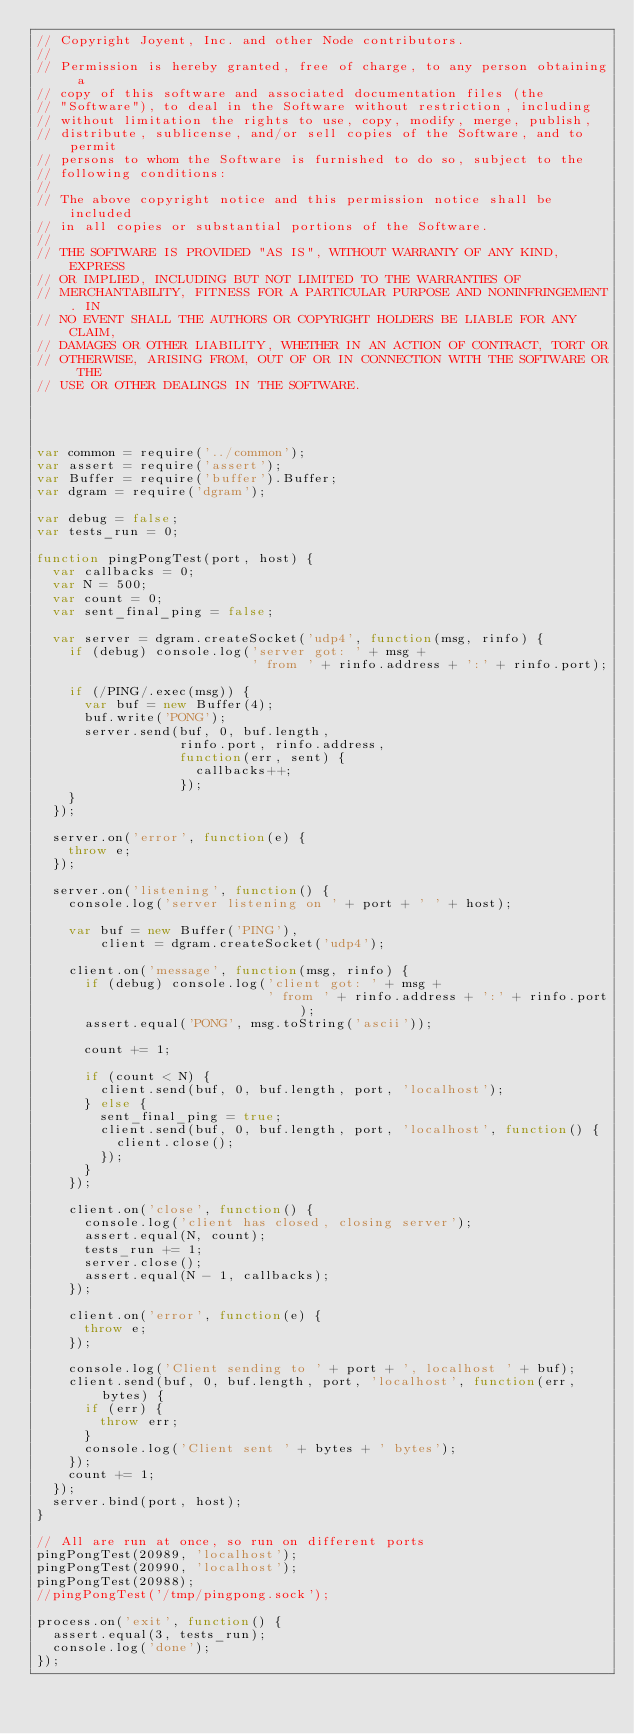<code> <loc_0><loc_0><loc_500><loc_500><_JavaScript_>// Copyright Joyent, Inc. and other Node contributors.
//
// Permission is hereby granted, free of charge, to any person obtaining a
// copy of this software and associated documentation files (the
// "Software"), to deal in the Software without restriction, including
// without limitation the rights to use, copy, modify, merge, publish,
// distribute, sublicense, and/or sell copies of the Software, and to permit
// persons to whom the Software is furnished to do so, subject to the
// following conditions:
//
// The above copyright notice and this permission notice shall be included
// in all copies or substantial portions of the Software.
//
// THE SOFTWARE IS PROVIDED "AS IS", WITHOUT WARRANTY OF ANY KIND, EXPRESS
// OR IMPLIED, INCLUDING BUT NOT LIMITED TO THE WARRANTIES OF
// MERCHANTABILITY, FITNESS FOR A PARTICULAR PURPOSE AND NONINFRINGEMENT. IN
// NO EVENT SHALL THE AUTHORS OR COPYRIGHT HOLDERS BE LIABLE FOR ANY CLAIM,
// DAMAGES OR OTHER LIABILITY, WHETHER IN AN ACTION OF CONTRACT, TORT OR
// OTHERWISE, ARISING FROM, OUT OF OR IN CONNECTION WITH THE SOFTWARE OR THE
// USE OR OTHER DEALINGS IN THE SOFTWARE.




var common = require('../common');
var assert = require('assert');
var Buffer = require('buffer').Buffer;
var dgram = require('dgram');

var debug = false;
var tests_run = 0;

function pingPongTest(port, host) {
  var callbacks = 0;
  var N = 500;
  var count = 0;
  var sent_final_ping = false;

  var server = dgram.createSocket('udp4', function(msg, rinfo) {
    if (debug) console.log('server got: ' + msg +
                           ' from ' + rinfo.address + ':' + rinfo.port);

    if (/PING/.exec(msg)) {
      var buf = new Buffer(4);
      buf.write('PONG');
      server.send(buf, 0, buf.length,
                  rinfo.port, rinfo.address,
                  function(err, sent) {
                    callbacks++;
                  });
    }
  });

  server.on('error', function(e) {
    throw e;
  });

  server.on('listening', function() {
    console.log('server listening on ' + port + ' ' + host);

    var buf = new Buffer('PING'),
        client = dgram.createSocket('udp4');

    client.on('message', function(msg, rinfo) {
      if (debug) console.log('client got: ' + msg +
                             ' from ' + rinfo.address + ':' + rinfo.port);
      assert.equal('PONG', msg.toString('ascii'));

      count += 1;

      if (count < N) {
        client.send(buf, 0, buf.length, port, 'localhost');
      } else {
        sent_final_ping = true;
        client.send(buf, 0, buf.length, port, 'localhost', function() {
          client.close();
        });
      }
    });

    client.on('close', function() {
      console.log('client has closed, closing server');
      assert.equal(N, count);
      tests_run += 1;
      server.close();
      assert.equal(N - 1, callbacks);
    });

    client.on('error', function(e) {
      throw e;
    });

    console.log('Client sending to ' + port + ', localhost ' + buf);
    client.send(buf, 0, buf.length, port, 'localhost', function(err, bytes) {
      if (err) {
        throw err;
      }
      console.log('Client sent ' + bytes + ' bytes');
    });
    count += 1;
  });
  server.bind(port, host);
}

// All are run at once, so run on different ports
pingPongTest(20989, 'localhost');
pingPongTest(20990, 'localhost');
pingPongTest(20988);
//pingPongTest('/tmp/pingpong.sock');

process.on('exit', function() {
  assert.equal(3, tests_run);
  console.log('done');
});
</code> 